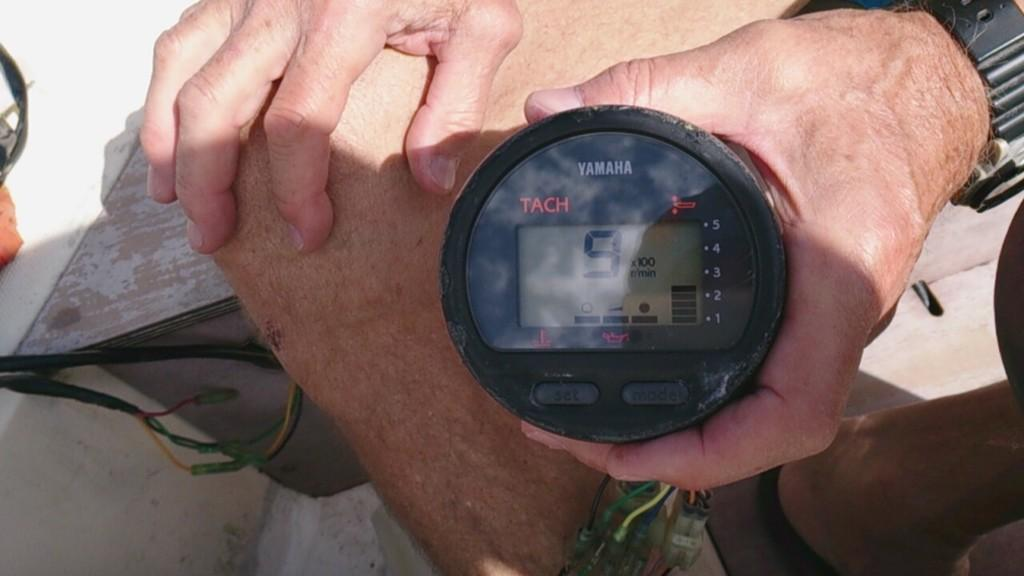<image>
Summarize the visual content of the image. A YAMAHA TACH meter with the number 9 on the display. 